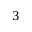<formula> <loc_0><loc_0><loc_500><loc_500>3</formula> 